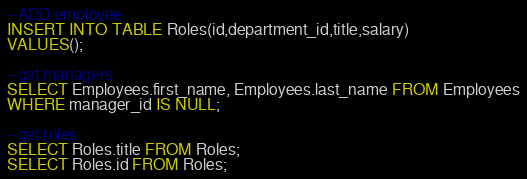<code> <loc_0><loc_0><loc_500><loc_500><_SQL_>
--ADD employee
INSERT INTO TABLE Roles(id,department_id,title,salary)
VALUES();

--get managers
SELECT Employees.first_name, Employees.last_name FROM Employees
WHERE manager_id IS NULL;

--get roles
SELECT Roles.title FROM Roles;
SELECT Roles.id FROM Roles;</code> 